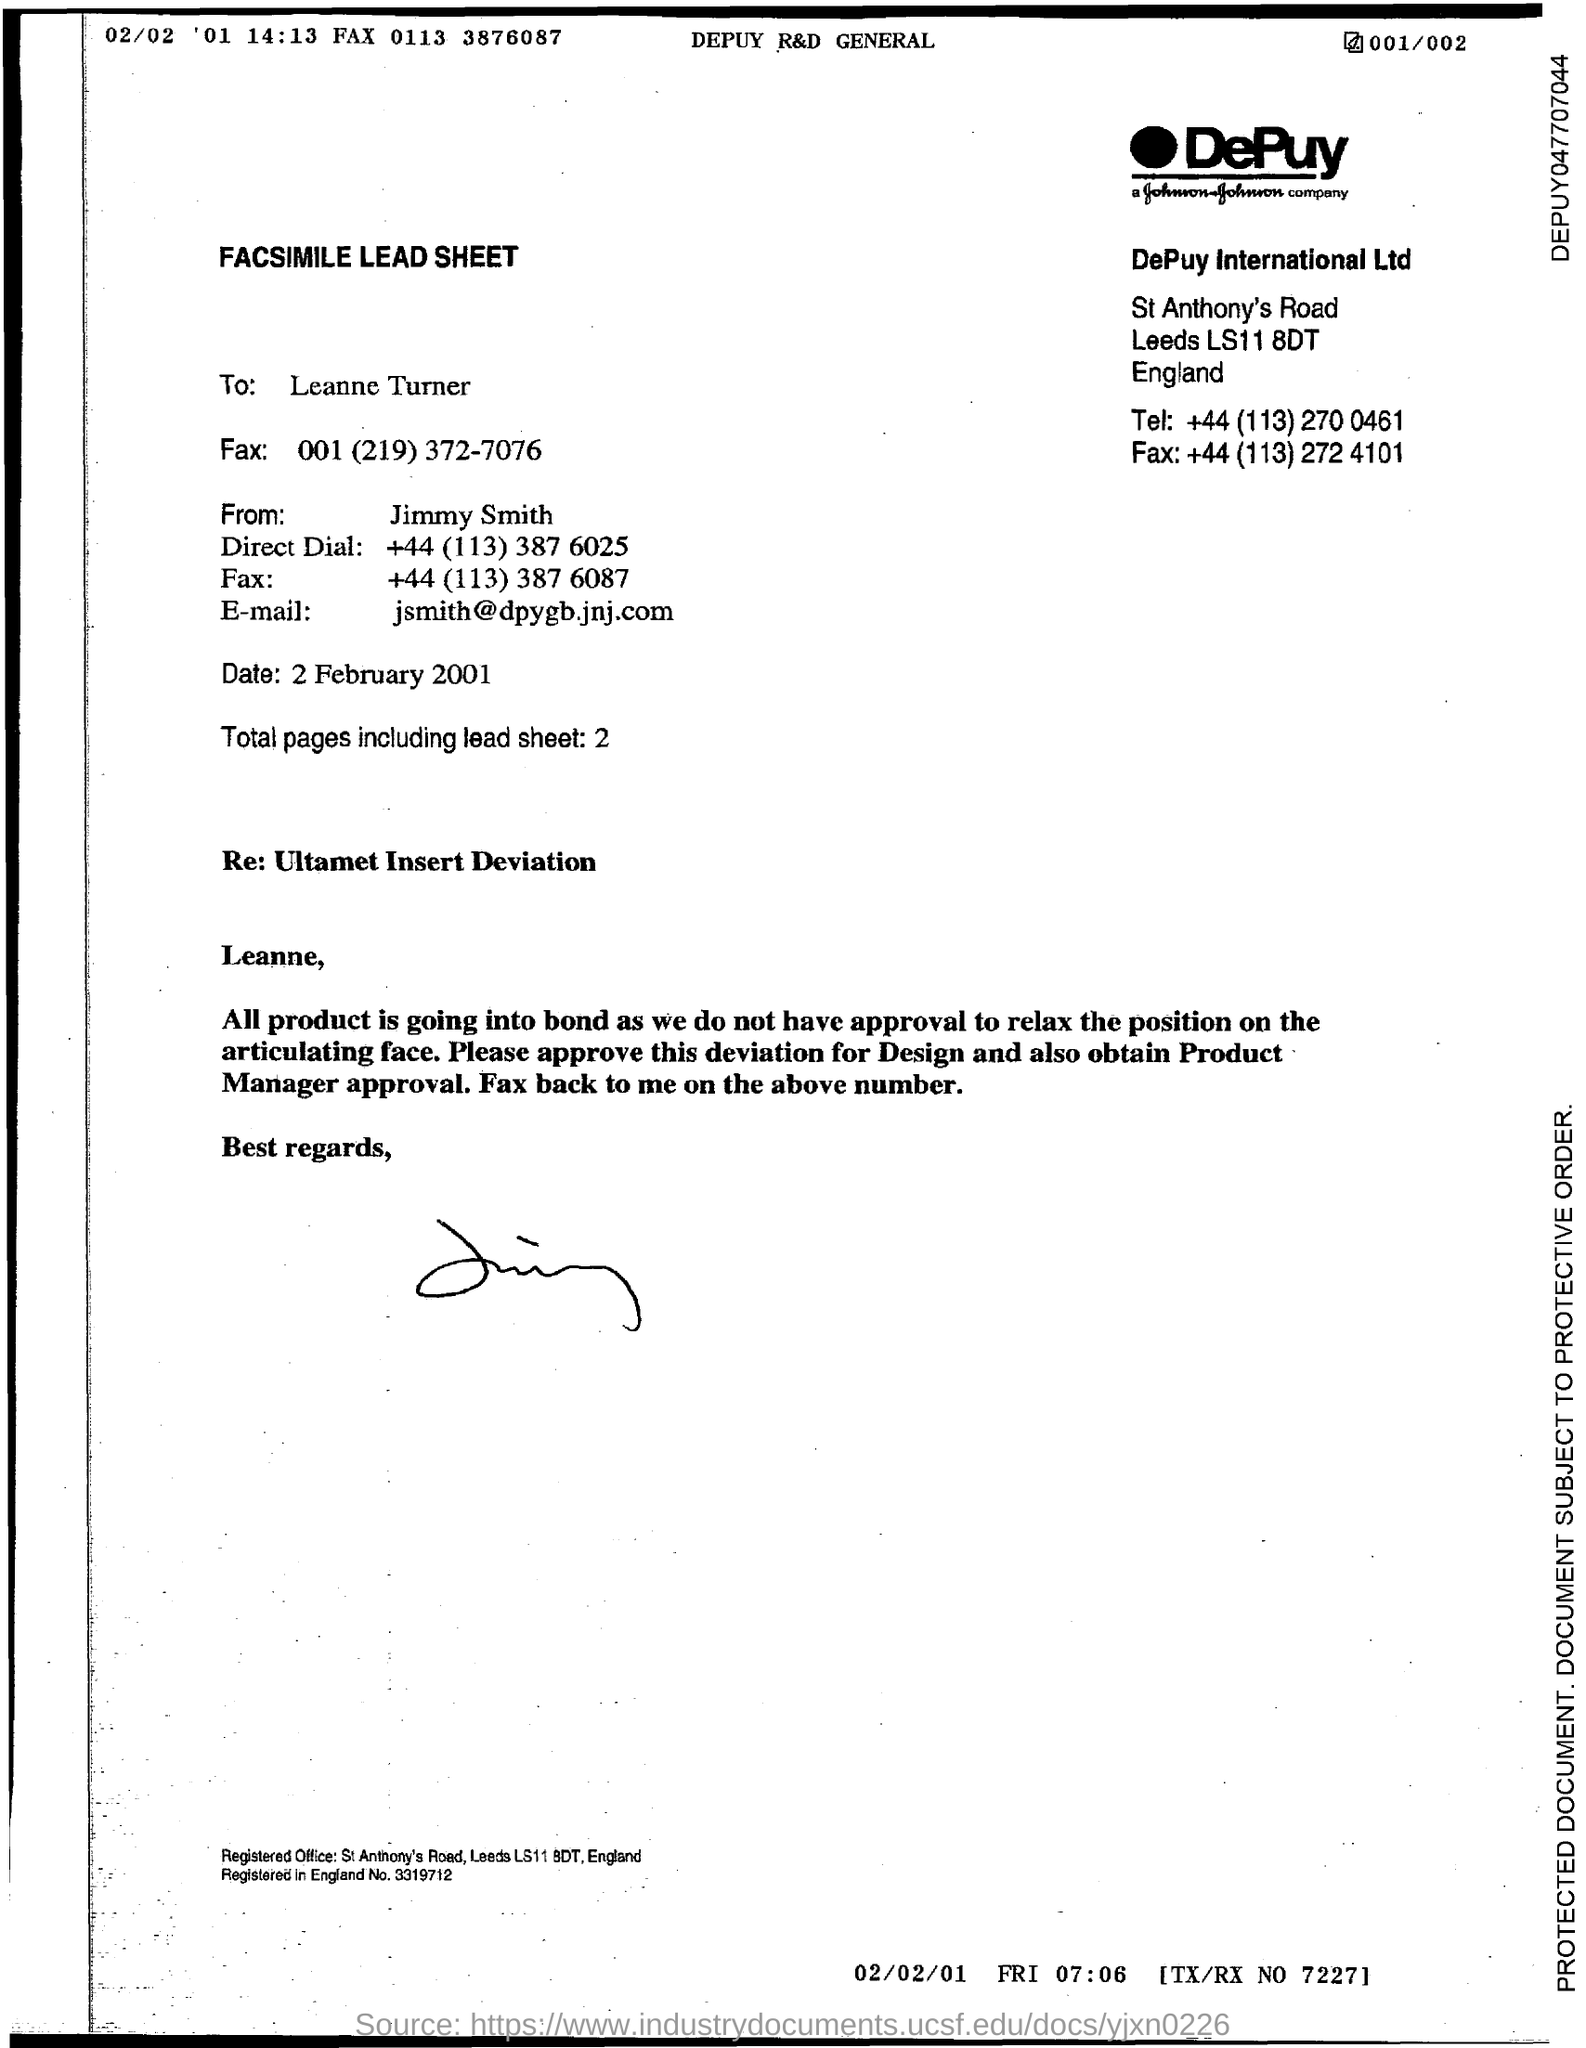What is the Email id?
Offer a very short reply. Jsmith@dpygb.jnj.com. What is the total number of pages including lead sheet?
Your answer should be very brief. 2. 